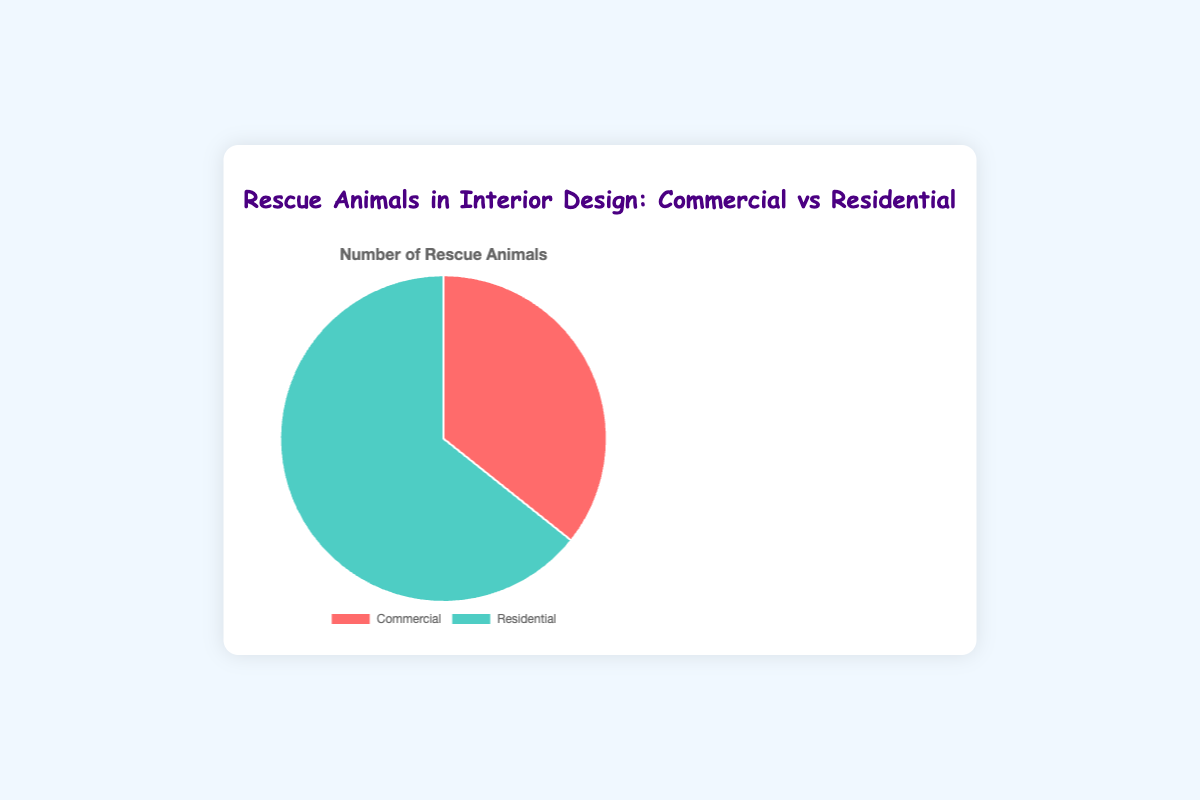What percentage of rescue animals are incorporated in residential designs? The chart shows that there are 180 rescue animals in residential designs, out of a total of 280 (100 in commercial + 180 in residential). To find the percentage, we use (180/280) * 100 = 64.29%
Answer: 64.29% Which sector incorporates more rescue animals, commercial or residential? The chart indicates that residential designs incorporate 180 rescue animals, while commercial designs incorporate 100. Therefore, residential designs have more rescue animals.
Answer: Residential What is the difference in the number of rescue animals between residential and commercial designs? The chart shows 180 rescue animals in residential designs and 100 in commercial designs. The difference is 180 - 100 = 80.
Answer: 80 What fraction of rescue animals are incorporated in commercial designs? There are 100 rescue animals in commercial designs out of a total of 280. This is calculated as 100/280, which reduces to 5/14.
Answer: 5/14 If we add 20 more rescue animals to residential designs, what will be the new percentage of rescue animals in residential designs? Initially, residential designs have 180 rescue animals out of a total of 280. Adding 20 to residential makes it 200, so the new total is 300. The new percentage is (200/300) * 100 = 66.67%
Answer: 66.67% Which color represents residential designs in the chart? The pie chart uses a specific color for each category. The segment for residential designs is depicted in green.
Answer: Green How many more rescue animals are in hotels compared to restaurants? From the data, hotels have 50 rescue animals, and restaurants have 30. The difference is 50 - 30 = 20.
Answer: 20 What portion of rescue animals in commercial designs are found in offices? In commercial designs, there are 50 (hotels) + 30 (restaurants) + 20 (offices) = 100. Offices have 20, so the portion is 20/100 = 1/5.
Answer: 1/5 